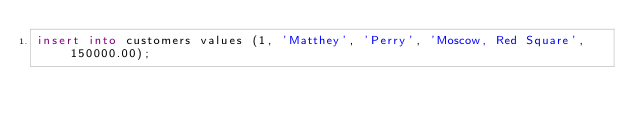Convert code to text. <code><loc_0><loc_0><loc_500><loc_500><_SQL_>insert into customers values (1, 'Matthey', 'Perry', 'Moscow, Red Square', 150000.00);</code> 